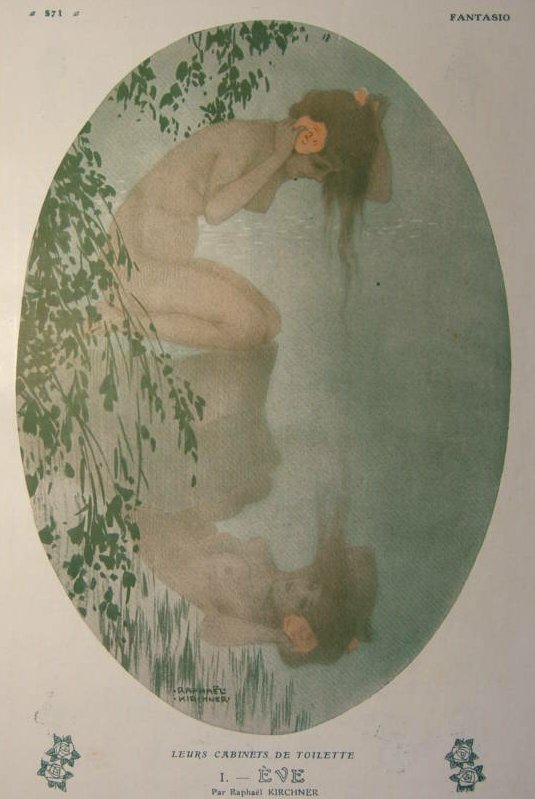Imagine discovering this artwork in an old attic. Describe the attic and your thoughts upon finding it. In the dim light of the old attic, dust particles danced in the slivers of sunlight filtering through the cracks in the wooden walls. Antique furniture draped in white sheets, stacks of forgotten books, and boxes overflowing with relics of a bygone era filled the room. As I shifted through the memories, a golden frame caught my eye, partially hidden behind a stack of vintage photographs. Pulling it out, I revealed the enchanting image of a woman by the water, her serenity a stark contrast to the chaos of the attic. The artwork, surrounded by an aura of quiet grace, seemed almost magical, transporting me to a place of calm and beauty amidst the attic's tangled past. It felt like uncovering a precious piece of history, a silent witness to a simpler, more enchanting time. 